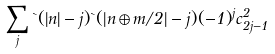<formula> <loc_0><loc_0><loc_500><loc_500>\sum _ { j } \theta ( | n | - j ) \theta ( | n \oplus m / 2 | - j ) ( - 1 ) ^ { j } c _ { 2 j - 1 } ^ { 2 }</formula> 